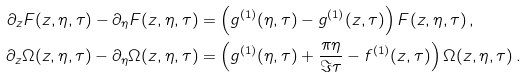Convert formula to latex. <formula><loc_0><loc_0><loc_500><loc_500>\partial _ { z } F ( z , \eta , \tau ) - \partial _ { \eta } F ( z , \eta , \tau ) & = \left ( g ^ { ( 1 ) } ( \eta , \tau ) - g ^ { ( 1 ) } ( z , \tau ) \right ) F ( z , \eta , \tau ) \, , \\ \partial _ { z } \Omega ( z , \eta , \tau ) - \partial _ { \eta } \Omega ( z , \eta , \tau ) & = \left ( g ^ { ( 1 ) } ( \eta , \tau ) + \frac { \pi \eta } { \Im \tau } - f ^ { ( 1 ) } ( z , \tau ) \right ) \Omega ( z , \eta , \tau ) \, .</formula> 